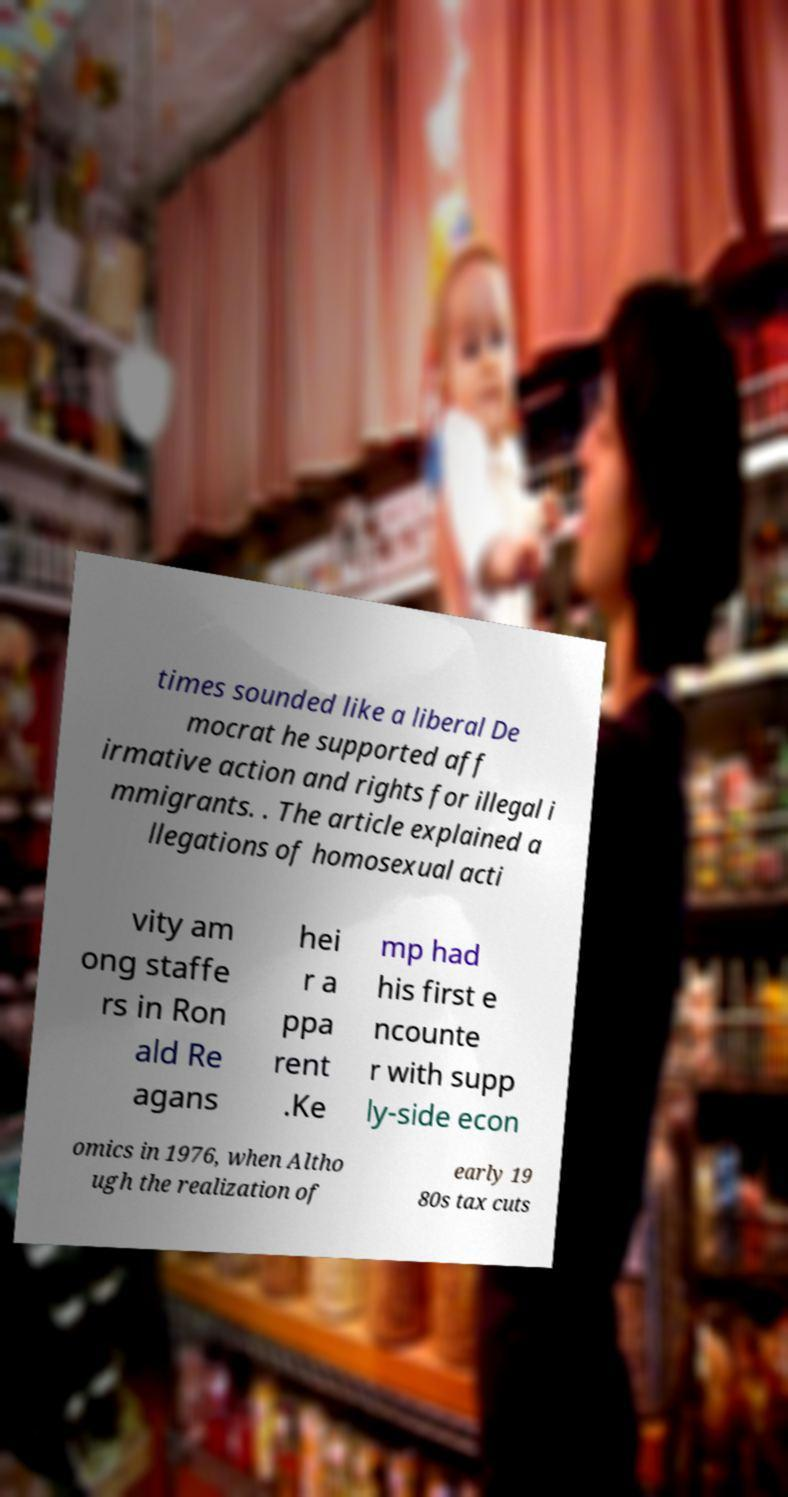Can you read and provide the text displayed in the image?This photo seems to have some interesting text. Can you extract and type it out for me? times sounded like a liberal De mocrat he supported aff irmative action and rights for illegal i mmigrants. . The article explained a llegations of homosexual acti vity am ong staffe rs in Ron ald Re agans hei r a ppa rent .Ke mp had his first e ncounte r with supp ly-side econ omics in 1976, when Altho ugh the realization of early 19 80s tax cuts 